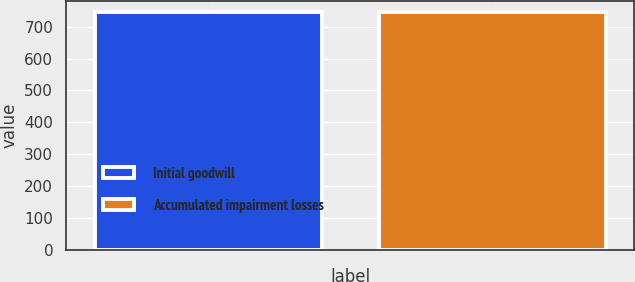Convert chart. <chart><loc_0><loc_0><loc_500><loc_500><bar_chart><fcel>Initial goodwill<fcel>Accumulated impairment losses<nl><fcel>745<fcel>745.1<nl></chart> 